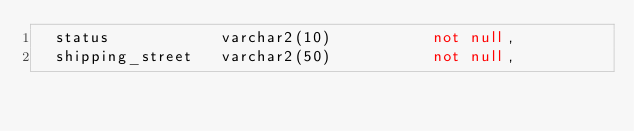Convert code to text. <code><loc_0><loc_0><loc_500><loc_500><_SQL_>  status            varchar2(10)           not null,
  shipping_street   varchar2(50)           not null,</code> 